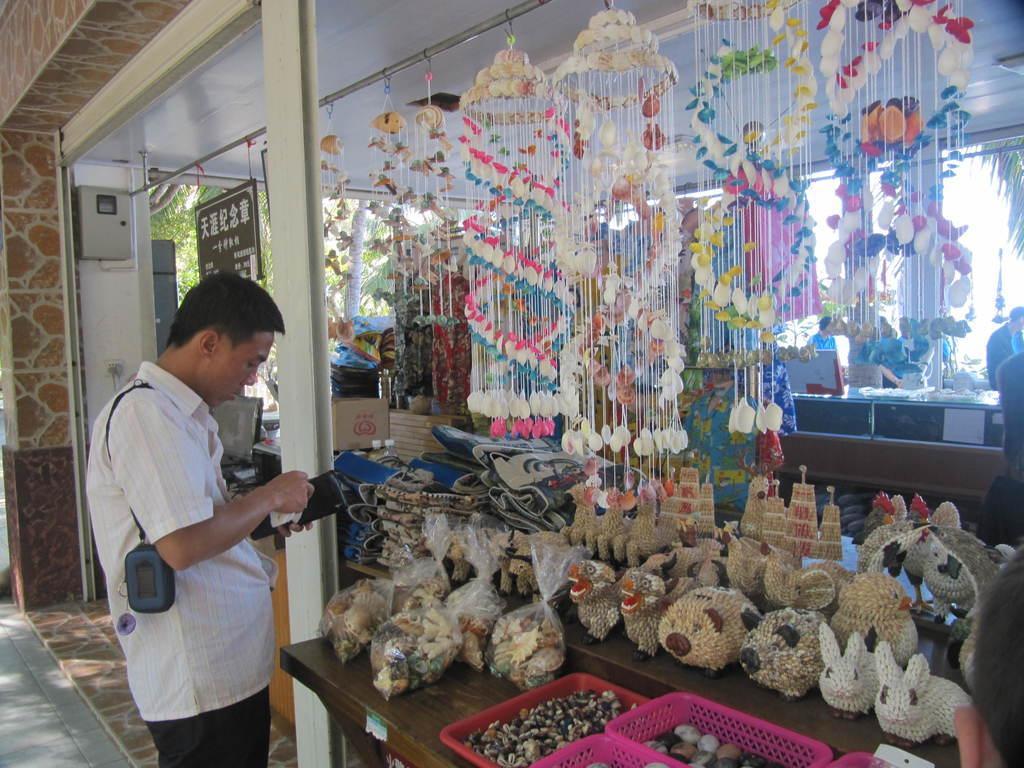Please provide a concise description of this image. A person is standing holding wallet. There are decor hangings, baskets and toys. There is a board at the back. People are present and there are trees at the back. 